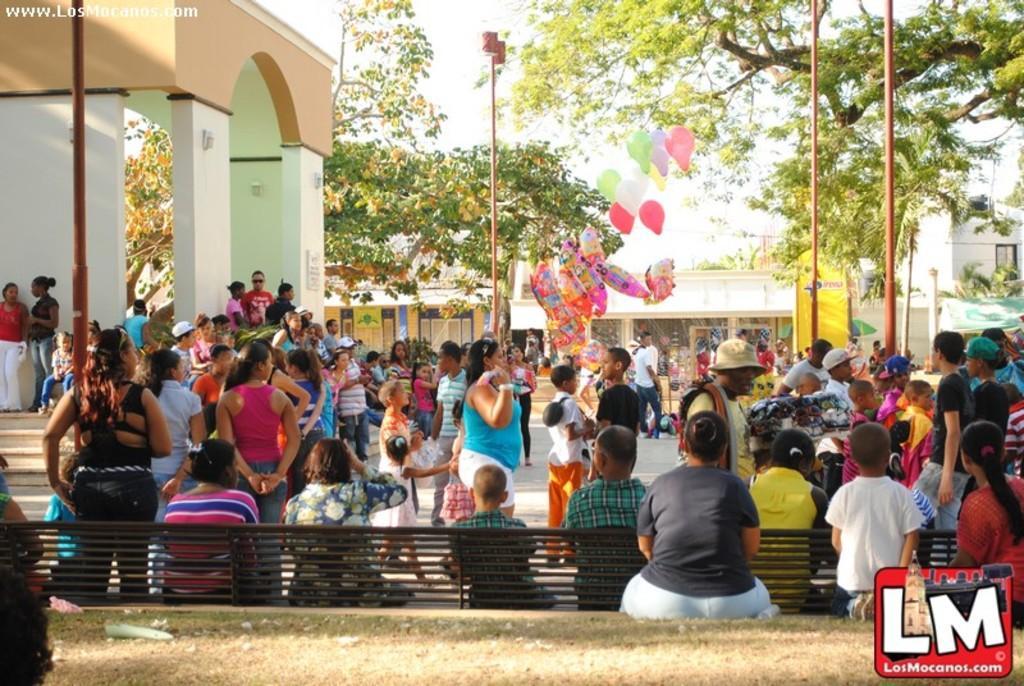In one or two sentences, can you explain what this image depicts? In this image in the center there are a group of people some of them are standing and some of them are sitting, and there are some balloons, poles and some trees and also we can see some boards, buildings. At the bottom of the image there is a bench, and there is a walkway and objects and on the left side of the image there are stairs. And on the right side of the image there is a tent and some plants, and in the bottom right hand corner there is a logo. 